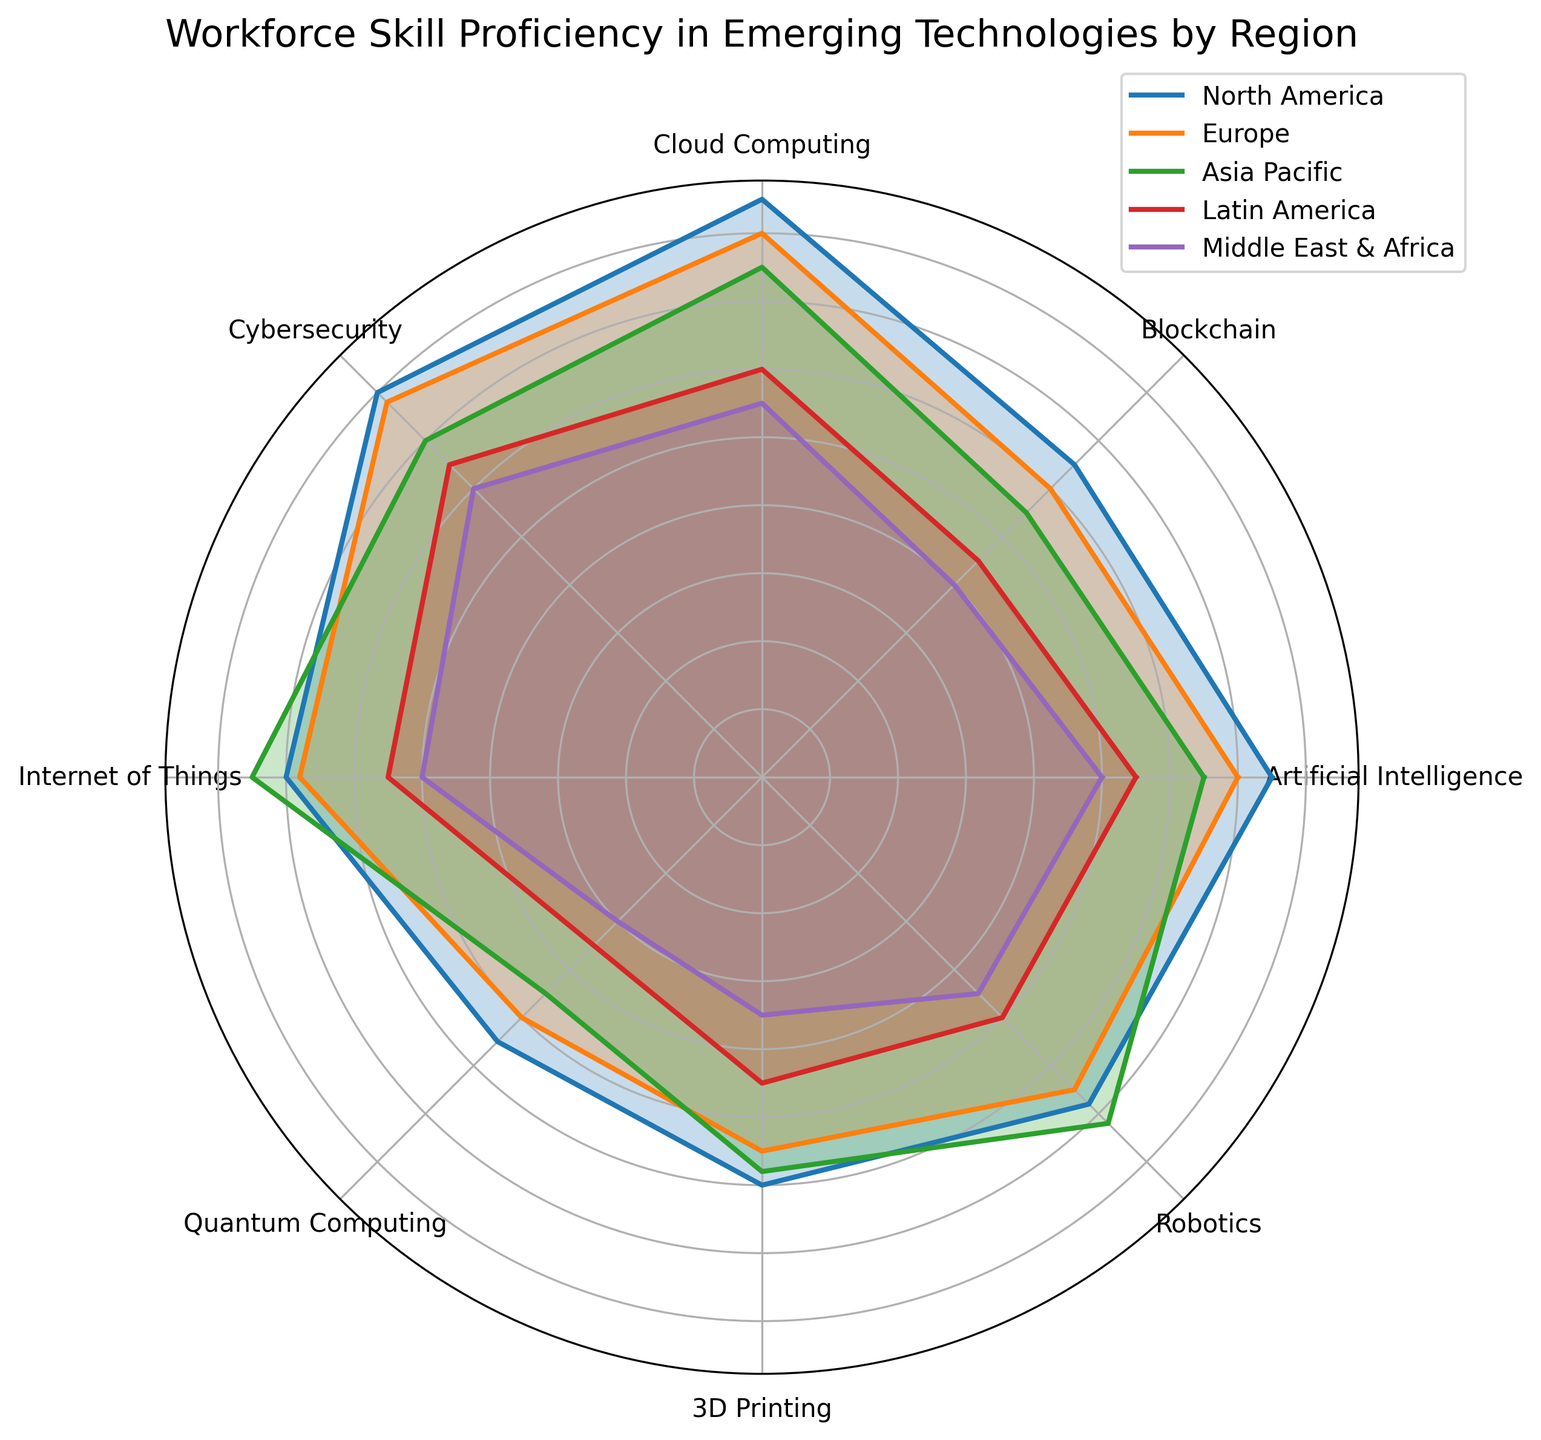What region shows the highest proficiency in Artificial Intelligence? North America's line reaches the farthest in the direction of the artificial intelligence axis, indicating the highest proficiency.
Answer: North America Which region has the lowest skill proficiency in Blockchain? The Middle East & Africa's line is closest to the center on the Blockchain axis, signaling the lowest proficiency.
Answer: Middle East & Africa Comparing North America and Europe, which region has higher proficiency in Cybersecurity? North America's line extends further on the Cybersecurity axis compared to Europe's, indicating a higher proficiency.
Answer: North America Calculate the average proficiency in Cloud Computing across all regions. The Cloud Computing scores are North America (85), Europe (80), Asia Pacific (75), Latin America (60), and the Middle East & Africa (55). Summing these scores gives 355, and the average is 355/5 = 71.
Answer: 71 Which regions have a Robotics proficiency higher than 65? By examining the Robotics axis, both Asia Pacific (72) and North America (68) have scores higher than 65.
Answer: North America, Asia Pacific What is the difference in Internet of Things proficiency between Asia Pacific and North America? Asia Pacific's proficiency in Internet of Things is 75, whereas North America's is 70. The difference is 75 - 70 = 5.
Answer: 5 Identify the region with the most consistent performance (least variation) across all categories. Visually inspecting the figure, Europe's data points are more evenly distributed around the perimeter. To verify, standard deviation calculation of values would indicate Europe has least variation.
Answer: Europe Which technology does the Middle East & Africa have the highest proficiency in, relatively speaking? The Middle East & Africa's line extends the furthest on the Cybersecurity axis compared to other technologies.
Answer: Cybersecurity Compare the skill proficiency in 3D Printing between Europe and Latin America. Who scores higher? Europe's line is slightly beyond the 55 mark on the 3D Printing axis, whereas Latin America's is around the 45 mark, making Europe's score higher.
Answer: Europe What is the summary trend of skill proficiency in Latin America compared to other regions? Latin America's lines are consistently closer to the center across most axes, suggesting generally lower proficiency compared to other regions.
Answer: Generally lower proficiency 